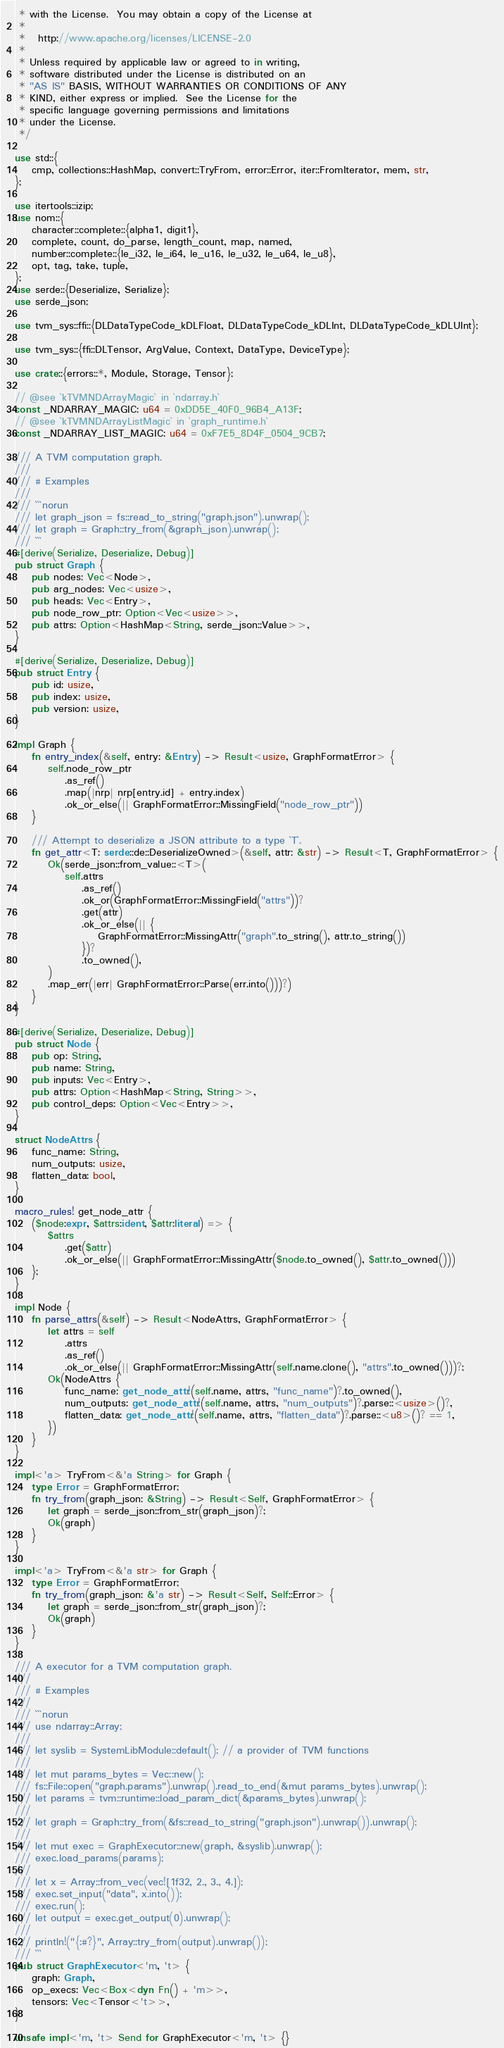<code> <loc_0><loc_0><loc_500><loc_500><_Rust_> * with the License.  You may obtain a copy of the License at
 *
 *   http://www.apache.org/licenses/LICENSE-2.0
 *
 * Unless required by applicable law or agreed to in writing,
 * software distributed under the License is distributed on an
 * "AS IS" BASIS, WITHOUT WARRANTIES OR CONDITIONS OF ANY
 * KIND, either express or implied.  See the License for the
 * specific language governing permissions and limitations
 * under the License.
 */

use std::{
    cmp, collections::HashMap, convert::TryFrom, error::Error, iter::FromIterator, mem, str,
};

use itertools::izip;
use nom::{
    character::complete::{alpha1, digit1},
    complete, count, do_parse, length_count, map, named,
    number::complete::{le_i32, le_i64, le_u16, le_u32, le_u64, le_u8},
    opt, tag, take, tuple,
};
use serde::{Deserialize, Serialize};
use serde_json;

use tvm_sys::ffi::{DLDataTypeCode_kDLFloat, DLDataTypeCode_kDLInt, DLDataTypeCode_kDLUInt};

use tvm_sys::{ffi::DLTensor, ArgValue, Context, DataType, DeviceType};

use crate::{errors::*, Module, Storage, Tensor};

// @see `kTVMNDArrayMagic` in `ndarray.h`
const _NDARRAY_MAGIC: u64 = 0xDD5E_40F0_96B4_A13F;
// @see `kTVMNDArrayListMagic` in `graph_runtime.h`
const _NDARRAY_LIST_MAGIC: u64 = 0xF7E5_8D4F_0504_9CB7;

/// A TVM computation graph.
///
/// # Examples
///
/// ```norun
/// let graph_json = fs::read_to_string("graph.json").unwrap();
/// let graph = Graph::try_from(&graph_json).unwrap();
/// ```
#[derive(Serialize, Deserialize, Debug)]
pub struct Graph {
    pub nodes: Vec<Node>,
    pub arg_nodes: Vec<usize>,
    pub heads: Vec<Entry>,
    pub node_row_ptr: Option<Vec<usize>>,
    pub attrs: Option<HashMap<String, serde_json::Value>>,
}

#[derive(Serialize, Deserialize, Debug)]
pub struct Entry {
    pub id: usize,
    pub index: usize,
    pub version: usize,
}

impl Graph {
    fn entry_index(&self, entry: &Entry) -> Result<usize, GraphFormatError> {
        self.node_row_ptr
            .as_ref()
            .map(|nrp| nrp[entry.id] + entry.index)
            .ok_or_else(|| GraphFormatError::MissingField("node_row_ptr"))
    }

    /// Attempt to deserialize a JSON attribute to a type `T`.
    fn get_attr<T: serde::de::DeserializeOwned>(&self, attr: &str) -> Result<T, GraphFormatError> {
        Ok(serde_json::from_value::<T>(
            self.attrs
                .as_ref()
                .ok_or(GraphFormatError::MissingField("attrs"))?
                .get(attr)
                .ok_or_else(|| {
                    GraphFormatError::MissingAttr("graph".to_string(), attr.to_string())
                })?
                .to_owned(),
        )
        .map_err(|err| GraphFormatError::Parse(err.into()))?)
    }
}

#[derive(Serialize, Deserialize, Debug)]
pub struct Node {
    pub op: String,
    pub name: String,
    pub inputs: Vec<Entry>,
    pub attrs: Option<HashMap<String, String>>,
    pub control_deps: Option<Vec<Entry>>,
}

struct NodeAttrs {
    func_name: String,
    num_outputs: usize,
    flatten_data: bool,
}

macro_rules! get_node_attr {
    ($node:expr, $attrs:ident, $attr:literal) => {
        $attrs
            .get($attr)
            .ok_or_else(|| GraphFormatError::MissingAttr($node.to_owned(), $attr.to_owned()))
    };
}

impl Node {
    fn parse_attrs(&self) -> Result<NodeAttrs, GraphFormatError> {
        let attrs = self
            .attrs
            .as_ref()
            .ok_or_else(|| GraphFormatError::MissingAttr(self.name.clone(), "attrs".to_owned()))?;
        Ok(NodeAttrs {
            func_name: get_node_attr!(self.name, attrs, "func_name")?.to_owned(),
            num_outputs: get_node_attr!(self.name, attrs, "num_outputs")?.parse::<usize>()?,
            flatten_data: get_node_attr!(self.name, attrs, "flatten_data")?.parse::<u8>()? == 1,
        })
    }
}

impl<'a> TryFrom<&'a String> for Graph {
    type Error = GraphFormatError;
    fn try_from(graph_json: &String) -> Result<Self, GraphFormatError> {
        let graph = serde_json::from_str(graph_json)?;
        Ok(graph)
    }
}

impl<'a> TryFrom<&'a str> for Graph {
    type Error = GraphFormatError;
    fn try_from(graph_json: &'a str) -> Result<Self, Self::Error> {
        let graph = serde_json::from_str(graph_json)?;
        Ok(graph)
    }
}

/// A executor for a TVM computation graph.
///
/// # Examples
///
/// ```norun
/// use ndarray::Array;
///
/// let syslib = SystemLibModule::default(); // a provider of TVM functions
///
/// let mut params_bytes = Vec::new();
/// fs::File::open("graph.params").unwrap().read_to_end(&mut params_bytes).unwrap();
/// let params = tvm::runtime::load_param_dict(&params_bytes).unwrap();
///
/// let graph = Graph::try_from(&fs::read_to_string("graph.json").unwrap()).unwrap();
///
/// let mut exec = GraphExecutor::new(graph, &syslib).unwrap();
/// exec.load_params(params);
///
/// let x = Array::from_vec(vec![1f32, 2., 3., 4.]);
/// exec.set_input("data", x.into());
/// exec.run();
/// let output = exec.get_output(0).unwrap();
///
/// println!("{:#?}", Array::try_from(output).unwrap());
/// ```
pub struct GraphExecutor<'m, 't> {
    graph: Graph,
    op_execs: Vec<Box<dyn Fn() + 'm>>,
    tensors: Vec<Tensor<'t>>,
}

unsafe impl<'m, 't> Send for GraphExecutor<'m, 't> {}
</code> 